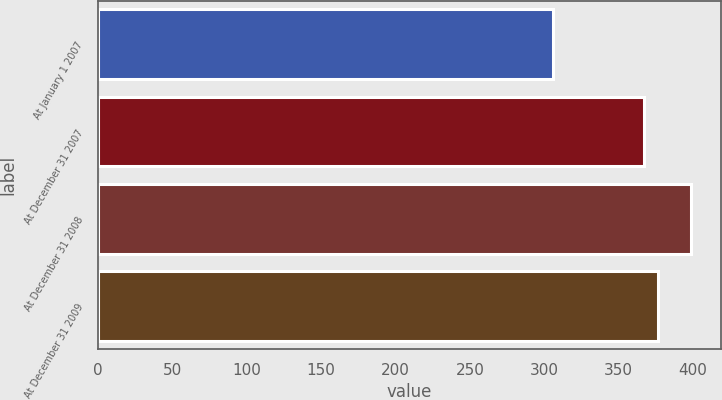Convert chart to OTSL. <chart><loc_0><loc_0><loc_500><loc_500><bar_chart><fcel>At January 1 2007<fcel>At December 31 2007<fcel>At December 31 2008<fcel>At December 31 2009<nl><fcel>306<fcel>367<fcel>399<fcel>376.3<nl></chart> 